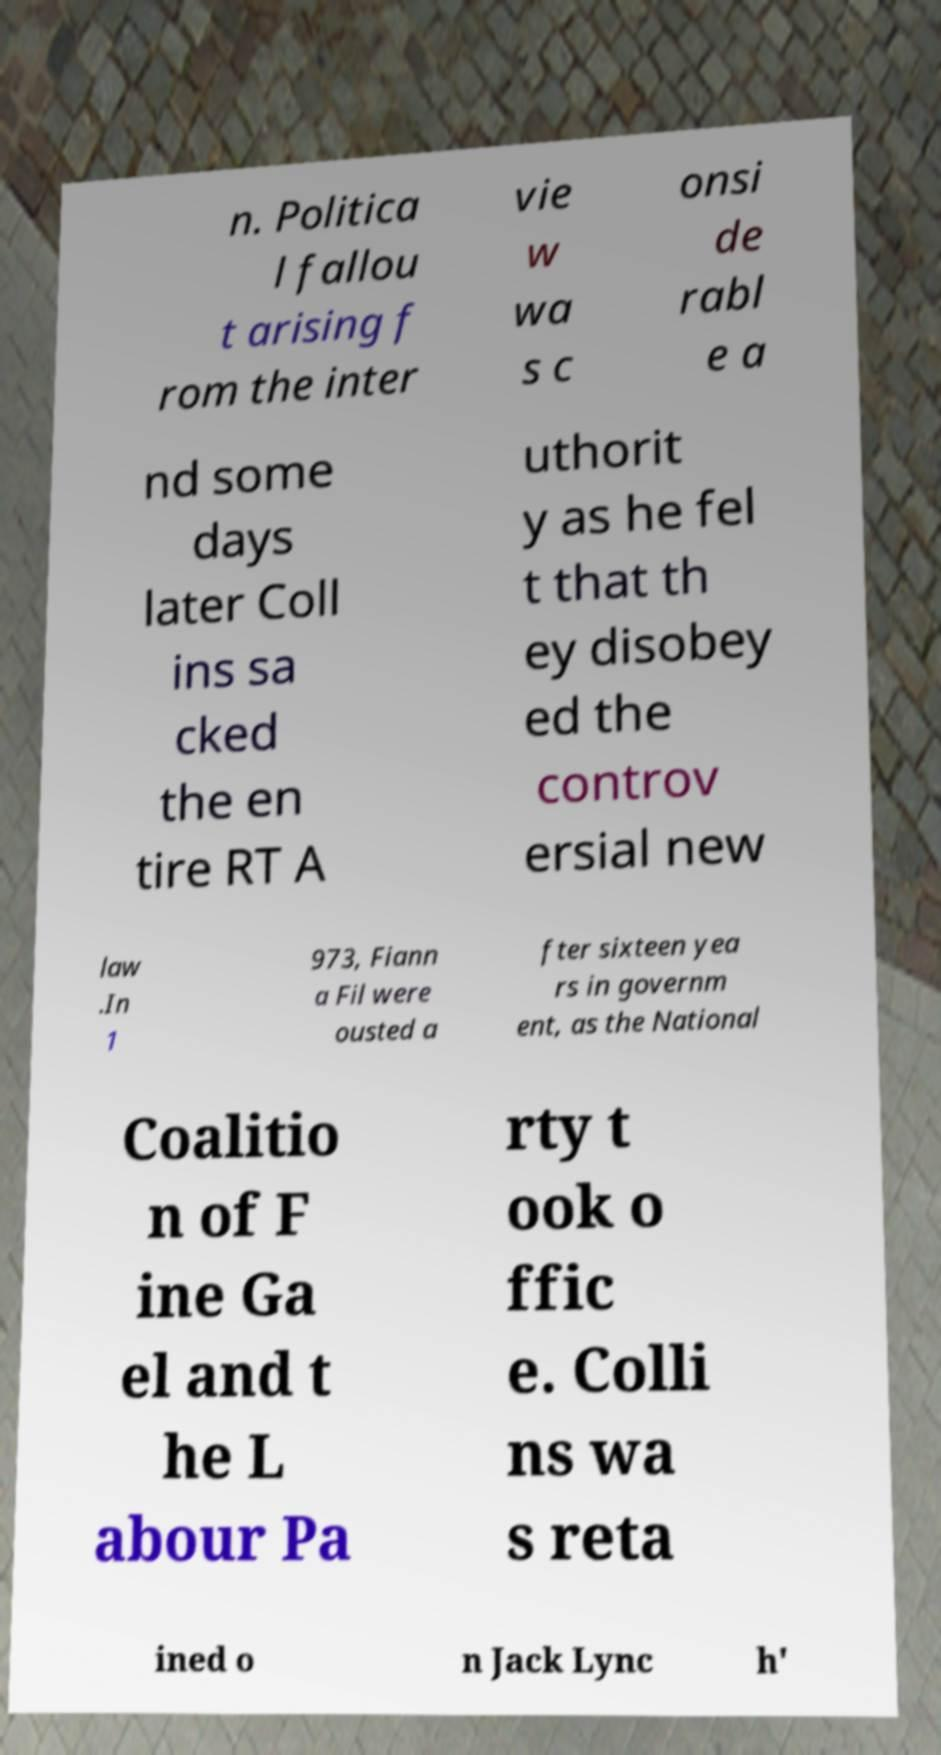For documentation purposes, I need the text within this image transcribed. Could you provide that? n. Politica l fallou t arising f rom the inter vie w wa s c onsi de rabl e a nd some days later Coll ins sa cked the en tire RT A uthorit y as he fel t that th ey disobey ed the controv ersial new law .In 1 973, Fiann a Fil were ousted a fter sixteen yea rs in governm ent, as the National Coalitio n of F ine Ga el and t he L abour Pa rty t ook o ffic e. Colli ns wa s reta ined o n Jack Lync h' 